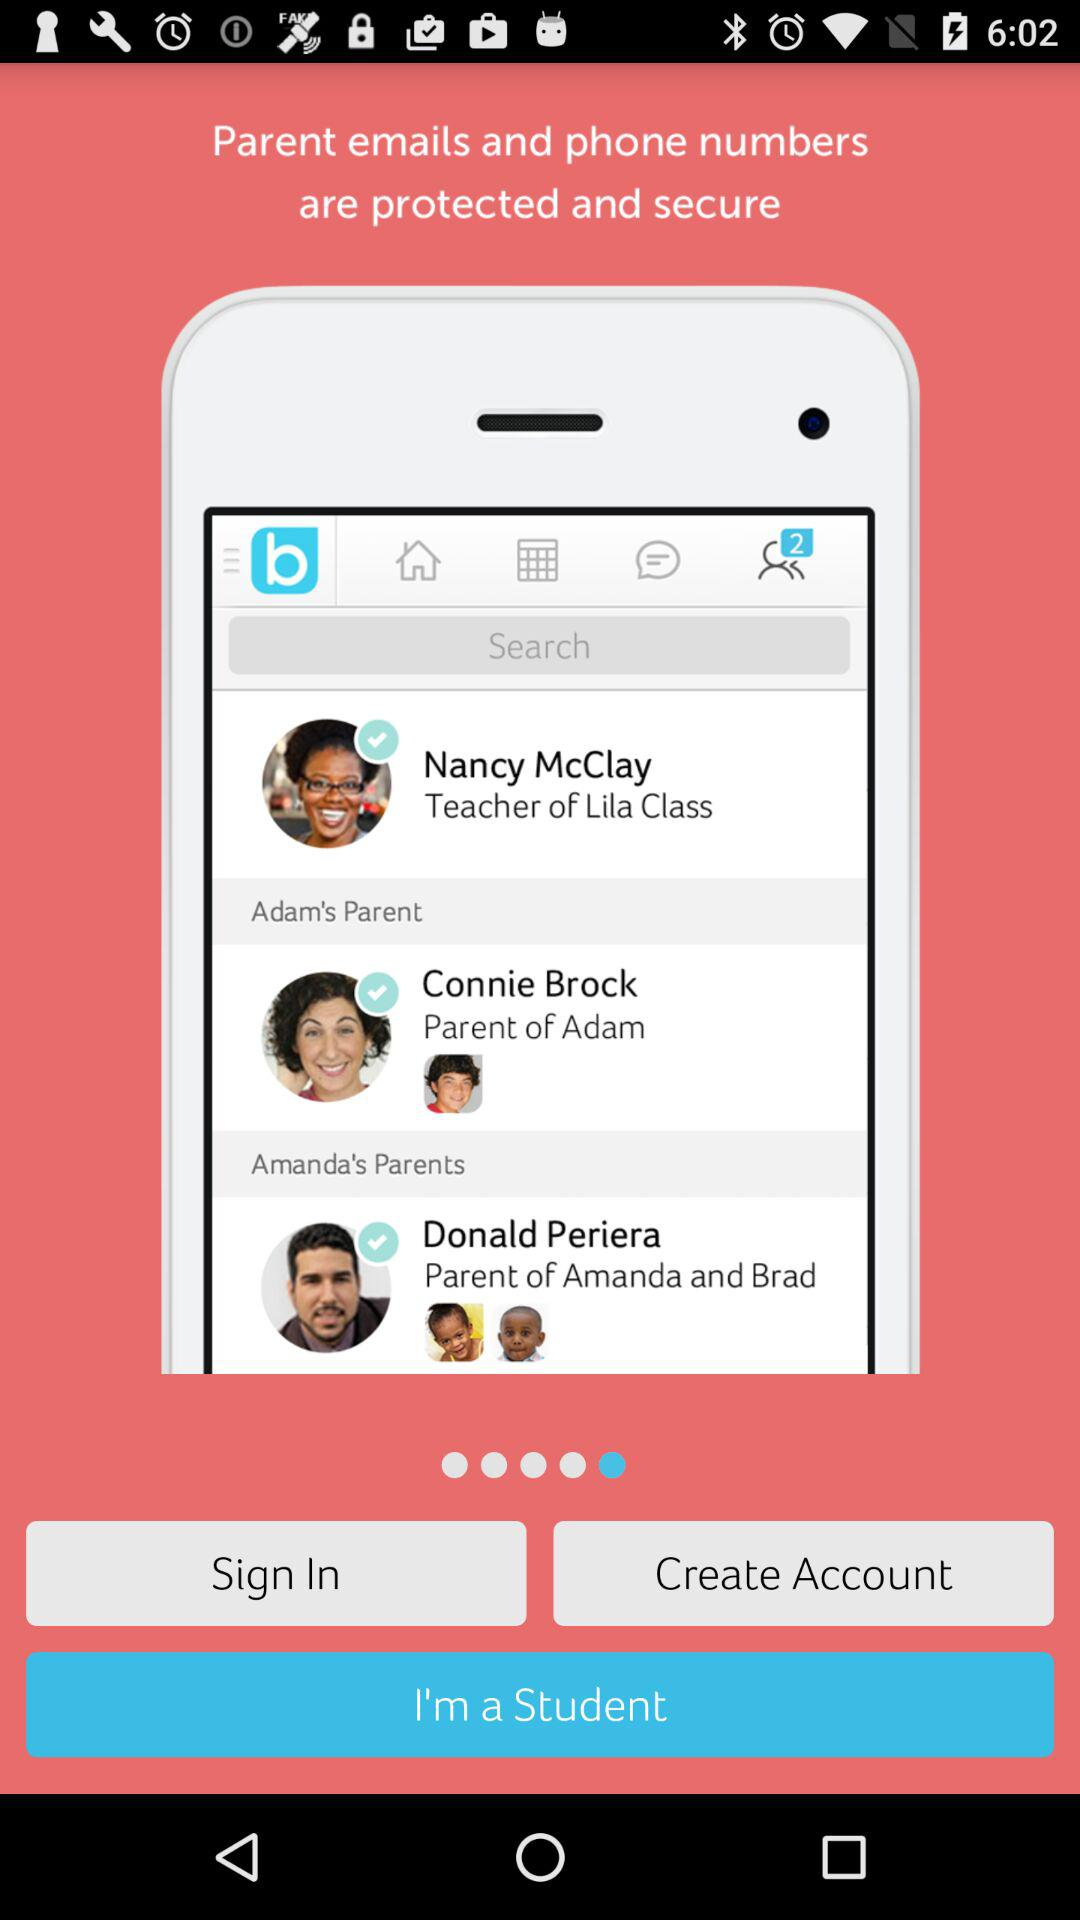Who is the parent of Adam? The parent of Adam is Connie Brock. 